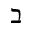<formula> <loc_0><loc_0><loc_500><loc_500>\beth</formula> 